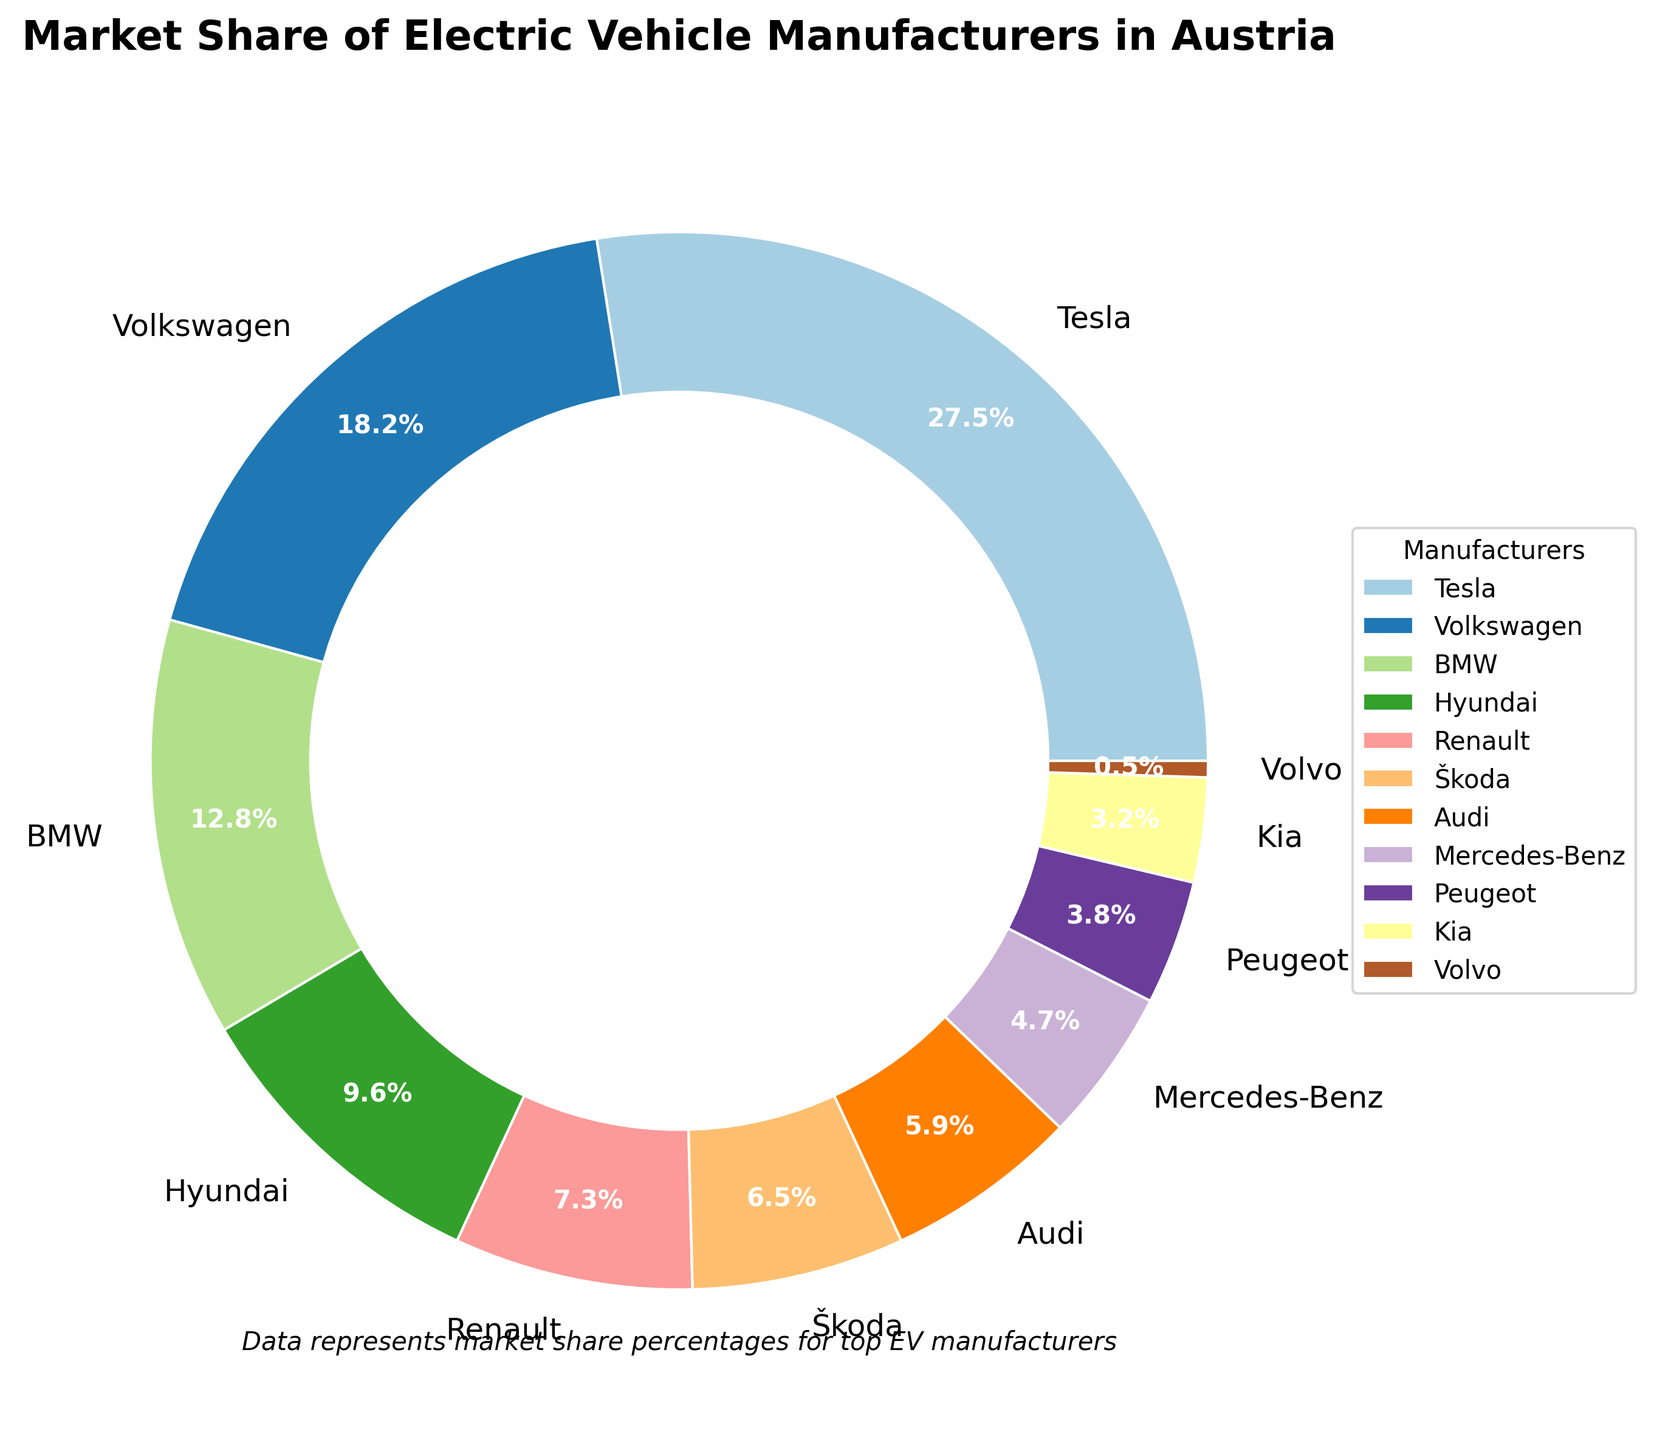Which manufacturer has the highest market share? The pie chart shows that Tesla has the largest portion of the donut chart.
Answer: Tesla What is the total market share of Volkswagen and BMW combined? Volkswagen and BMW have market shares of 18.2% and 12.8%, respectively. Adding these together gives 18.2 + 12.8 = 31.0%.
Answer: 31.0% How much larger is Tesla's market share compared to Mercedes-Benz? Tesla has a market share of 27.5%, while Mercedes-Benz has 4.7%. Subtracting these gives 27.5 - 4.7 = 22.8%.
Answer: 22.8% Which manufacturer has a market share closest to 10%? The pie chart shows that Hyundai has the closest market share to 10% at 9.6%.
Answer: Hyundai What is the combined market share of the manufacturers with less than 5% each? Manufacturers with less than 5% market share are Mercedes-Benz (4.7%), Peugeot (3.8%), Kia (3.2%), and Volvo (0.5%). Adding these together gives 4.7 + 3.8 + 3.2 + 0.5 = 12.2%.
Answer: 12.2% How many manufacturers have a market share greater than 10%? The manufacturers with market shares greater than 10% are Tesla (27.5%), Volkswagen (18.2%), and BMW (12.8%). There are 3 of them.
Answer: 3 Which manufacturer has the smallest market share and what is it? The smallest market share is held by Volvo, which has 0.5%.
Answer: Volvo, 0.5% What is the average market share of the manufacturers listed? Sum of the market shares is 27.5 + 18.2 + 12.8 + 9.6 + 7.3 + 6.5 + 5.9 + 4.7 + 3.8 + 3.2 + 0.5 = 100%. There are 11 manufacturers, so the average is 100 / 11 = 9.1%.
Answer: 9.1% Which manufacturers have market shares between 5% and 10% inclusive? The pie chart shows that Hyundai (9.6%), Renault (7.3%), Škoda (6.5%), and Audi (5.9%) fall within this range.
Answer: Hyundai, Renault, Škoda, Audi 